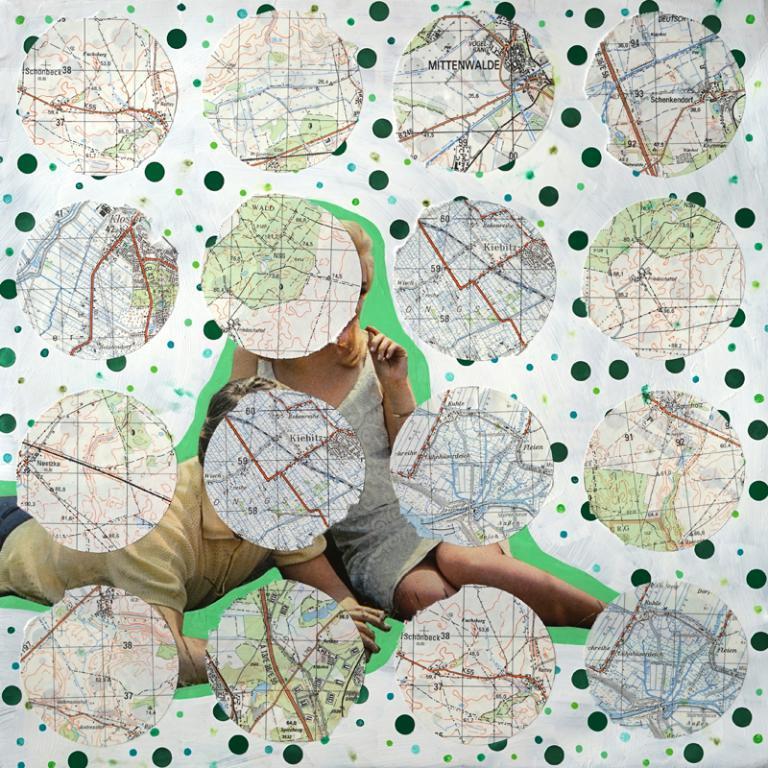Could you give a brief overview of what you see in this image? This is an edited image and here we can see people and there are logos and some text. 